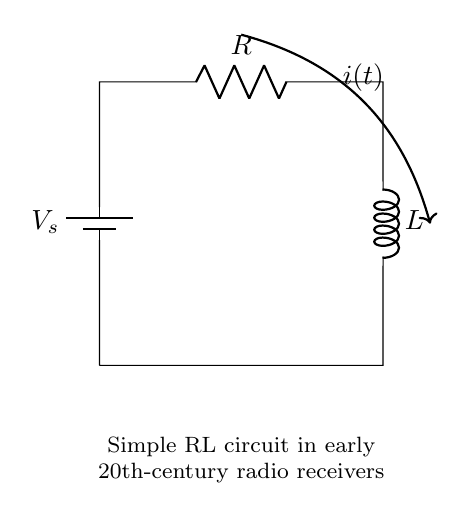What is the total number of components in the circuit? The circuit consists of three components: one battery, one resistor, and one inductor.
Answer: three What is the function of the resistor in this circuit? The resistor limits the current flow, providing resistance in the circuit, which is essential for controlling the voltage across the inductor.
Answer: limit current What is the role of the inductor in this circuit? The inductor stores energy in a magnetic field when current flows through it and opposes changes in current, which is crucial for signal processing in radio receivers.
Answer: store energy What is the type of connection between the resistor and inductor? The resistor and inductor are connected in series, meaning the current flows through both components sequentially.
Answer: series What happens to current initially when the circuit is powered on? When the circuit is first powered, the current is zero due to the inductor opposing the change in current. Over time, the current increases as the magnetic field builds up.
Answer: zero How does the inductor affect the overall circuit performance in a radio receiver? The inductor's property of opposing changes in current helps filter signals and resonates with specific frequencies, which improves the quality of received radio signals.
Answer: filter signals 